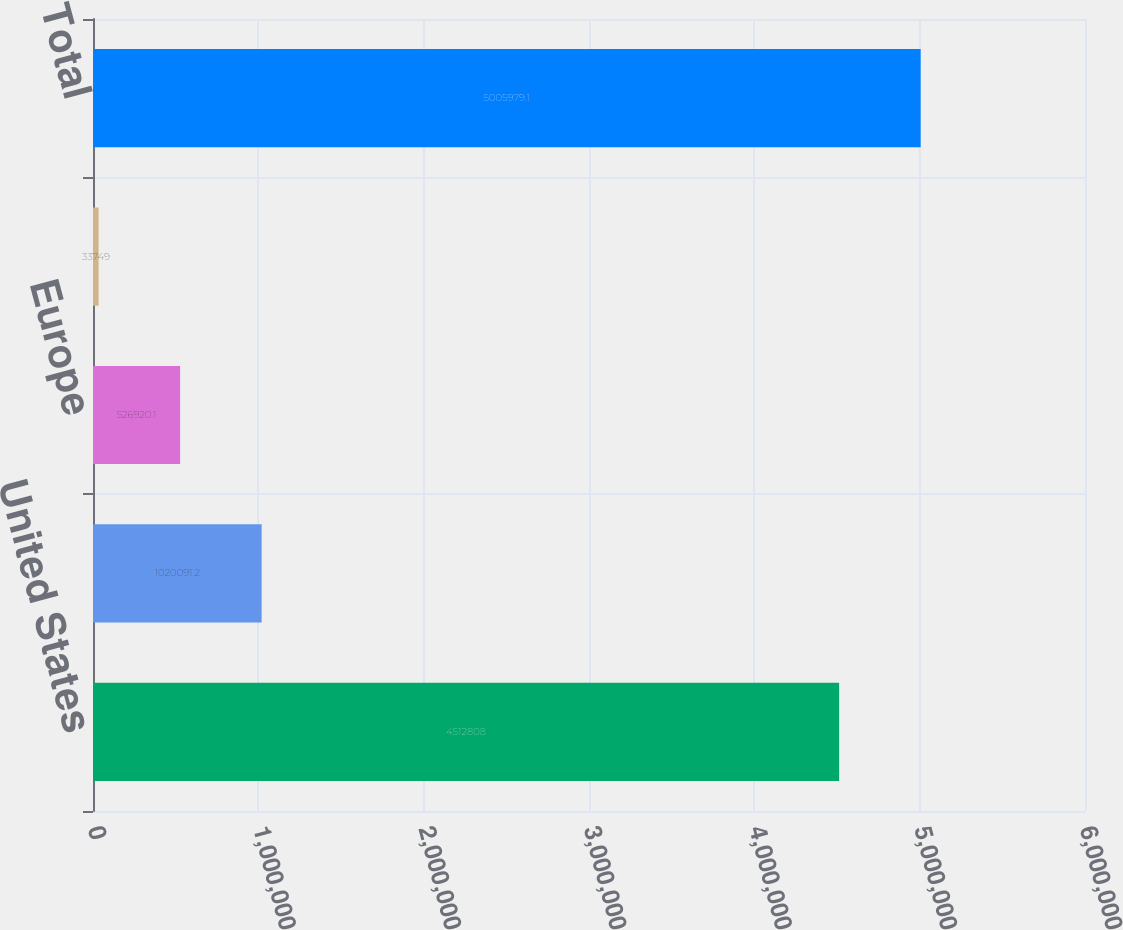Convert chart. <chart><loc_0><loc_0><loc_500><loc_500><bar_chart><fcel>United States<fcel>Canada<fcel>Europe<fcel>Other<fcel>Total<nl><fcel>4.51281e+06<fcel>1.02009e+06<fcel>526920<fcel>33749<fcel>5.00598e+06<nl></chart> 